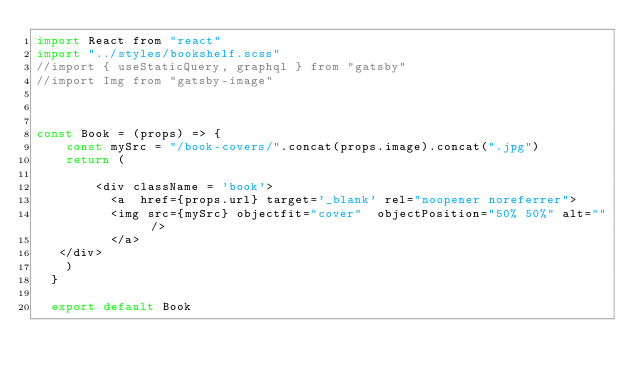<code> <loc_0><loc_0><loc_500><loc_500><_JavaScript_>import React from "react"
import "../styles/bookshelf.scss"
//import { useStaticQuery, graphql } from "gatsby"
//import Img from "gatsby-image"



const Book = (props) => {
    const mySrc = "/book-covers/".concat(props.image).concat(".jpg")
    return (
        
        <div className = 'book'>
          <a  href={props.url} target='_blank' rel="noopener noreferrer">
          <img src={mySrc} objectfit="cover"  objectPosition="50% 50%" alt="" />
          </a>
   </div>  
    )
  }
  
  export default Book</code> 